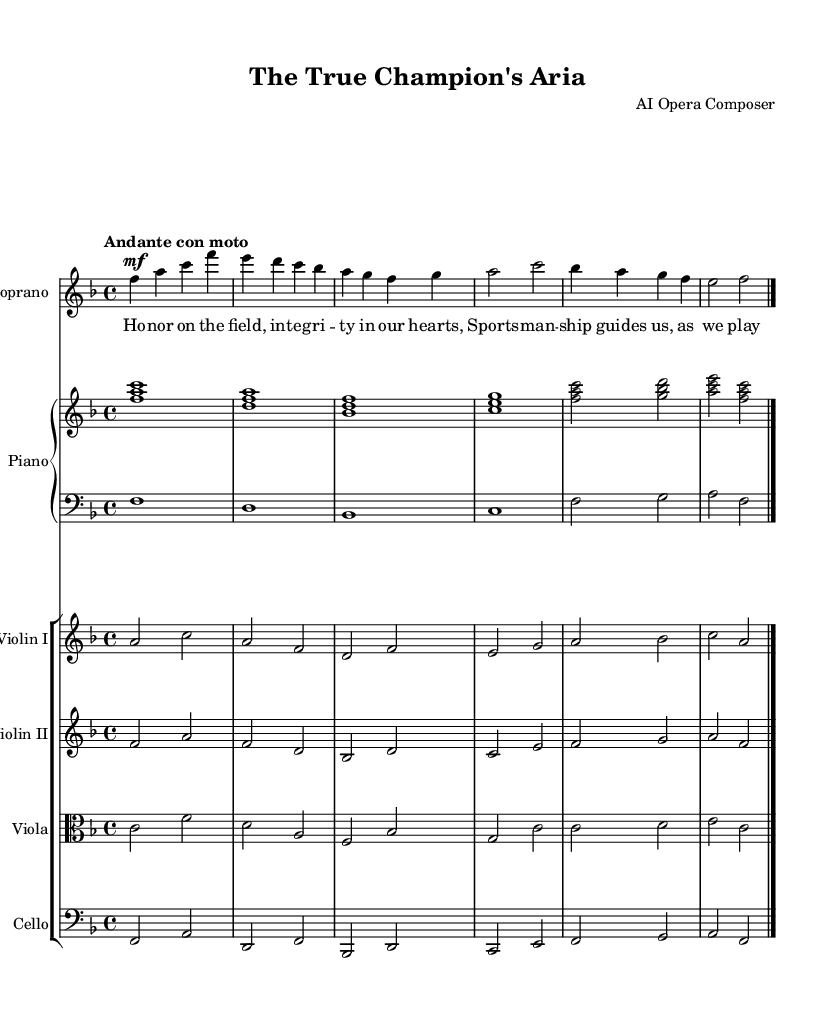What is the key signature of this music? The key signature in this music is F major, indicated by one flat (B♭). This can be seen in the key signature section at the beginning of the score.
Answer: F major What is the time signature of this music? The time signature is 4/4, which is shown at the beginning of the score. This means there are four beats in each measure, and the quarter note gets one beat.
Answer: 4/4 What is the tempo marking of this music? The tempo marking is "Andante con moto", which is stated at the beginning of the score. This indicates a moderately slow tempo with a bit of movement.
Answer: Andante con moto How many voices are present in the score? The score features one voice, specifically the soprano voice, along with instrumental parts for piano and strings. The presence of the 'new Voice' indicates a single vocal line.
Answer: One voice What is the primary theme expressed in the lyrics? The primary theme expressed in the lyrics revolves around honor, integrity, and sportsmanship. These concepts are emphasized in the lyric lines that describe character values in sports.
Answer: Honor, integrity, sportsmanship Which instrument plays the lowest part in the arrangement? The cello plays the lowest part in the arrangement, as it is written in the bass clef and primarily features lowest pitches compared to the other string instruments.
Answer: Cello 